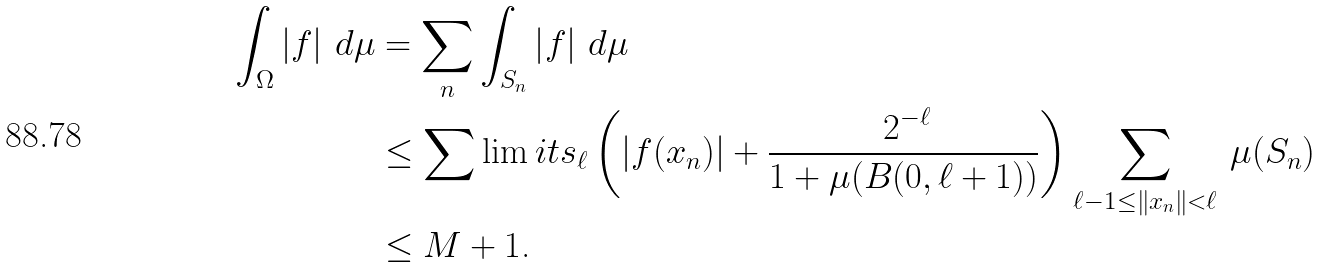<formula> <loc_0><loc_0><loc_500><loc_500>\int _ { \Omega } \left | f \right | \, d \mu & = \sum _ { n } \int _ { S _ { n } } \left | f \right | \, d \mu \\ & \leq \sum \lim i t s _ { \ell } \left ( \left | f ( x _ { n } ) \right | + \frac { \, 2 ^ { - \ell } } { 1 + \mu ( B ( 0 , \ell + 1 ) ) } \right ) \sum _ { \ell - 1 \leq \left \| x _ { n } \right \| < \ell } \, \mu ( S _ { n } ) \\ & \leq M + 1 \text {.}</formula> 